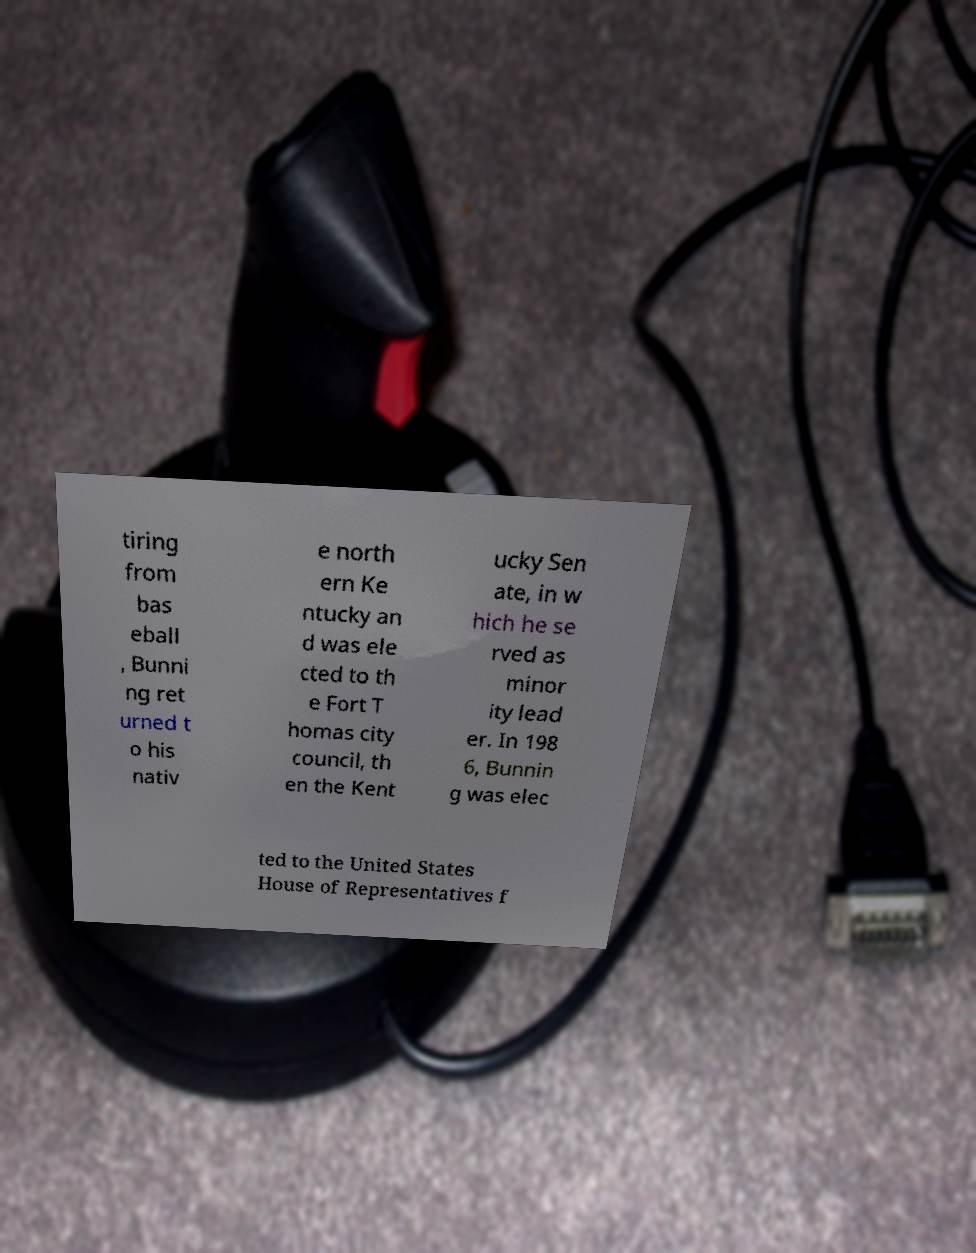Please identify and transcribe the text found in this image. tiring from bas eball , Bunni ng ret urned t o his nativ e north ern Ke ntucky an d was ele cted to th e Fort T homas city council, th en the Kent ucky Sen ate, in w hich he se rved as minor ity lead er. In 198 6, Bunnin g was elec ted to the United States House of Representatives f 